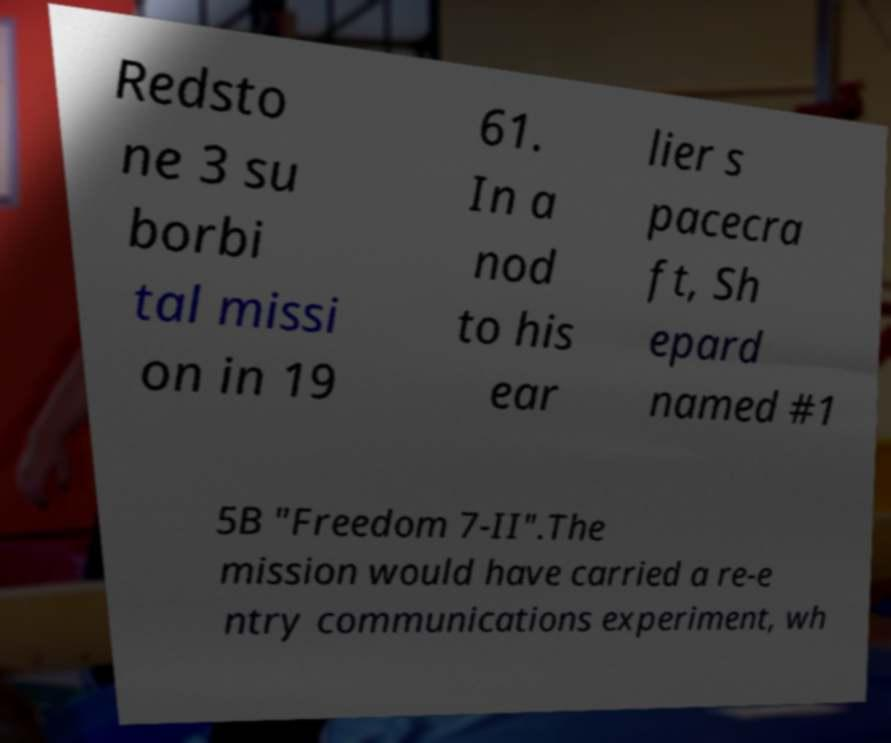Could you extract and type out the text from this image? Redsto ne 3 su borbi tal missi on in 19 61. In a nod to his ear lier s pacecra ft, Sh epard named #1 5B "Freedom 7-II".The mission would have carried a re-e ntry communications experiment, wh 